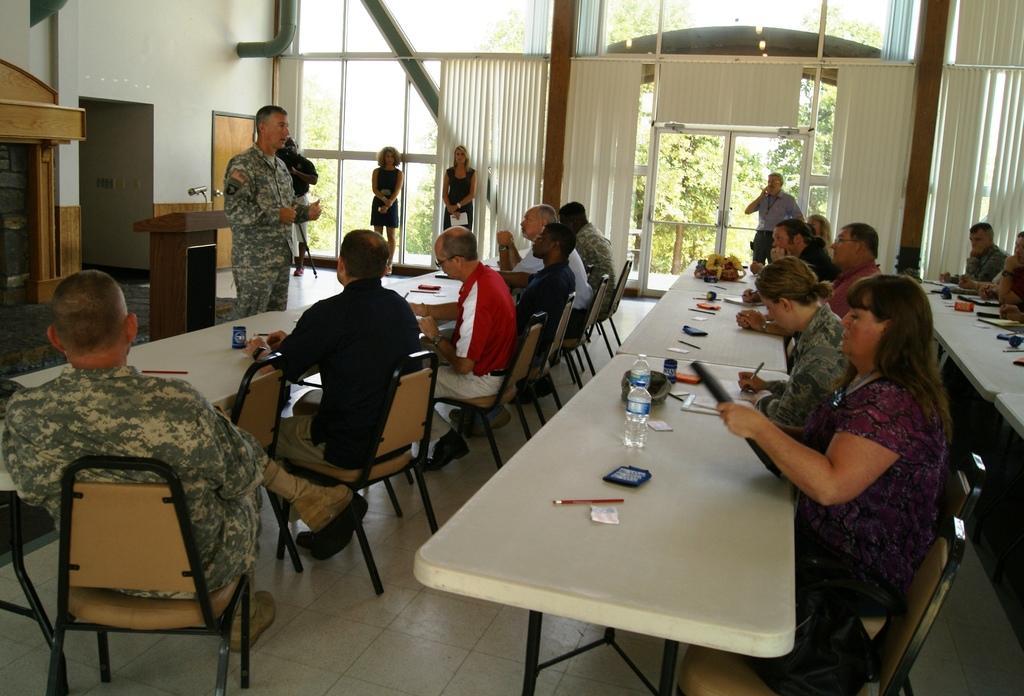Please provide a concise description of this image. Here we can see few persons sitting on chairs in front of a table and on the table we can see mobiles, water bottles. This is a floor. We can see five persons standing here. this is a podium and mike. These are doors and windows. Through window glasses we can see trees. This is a wall. 